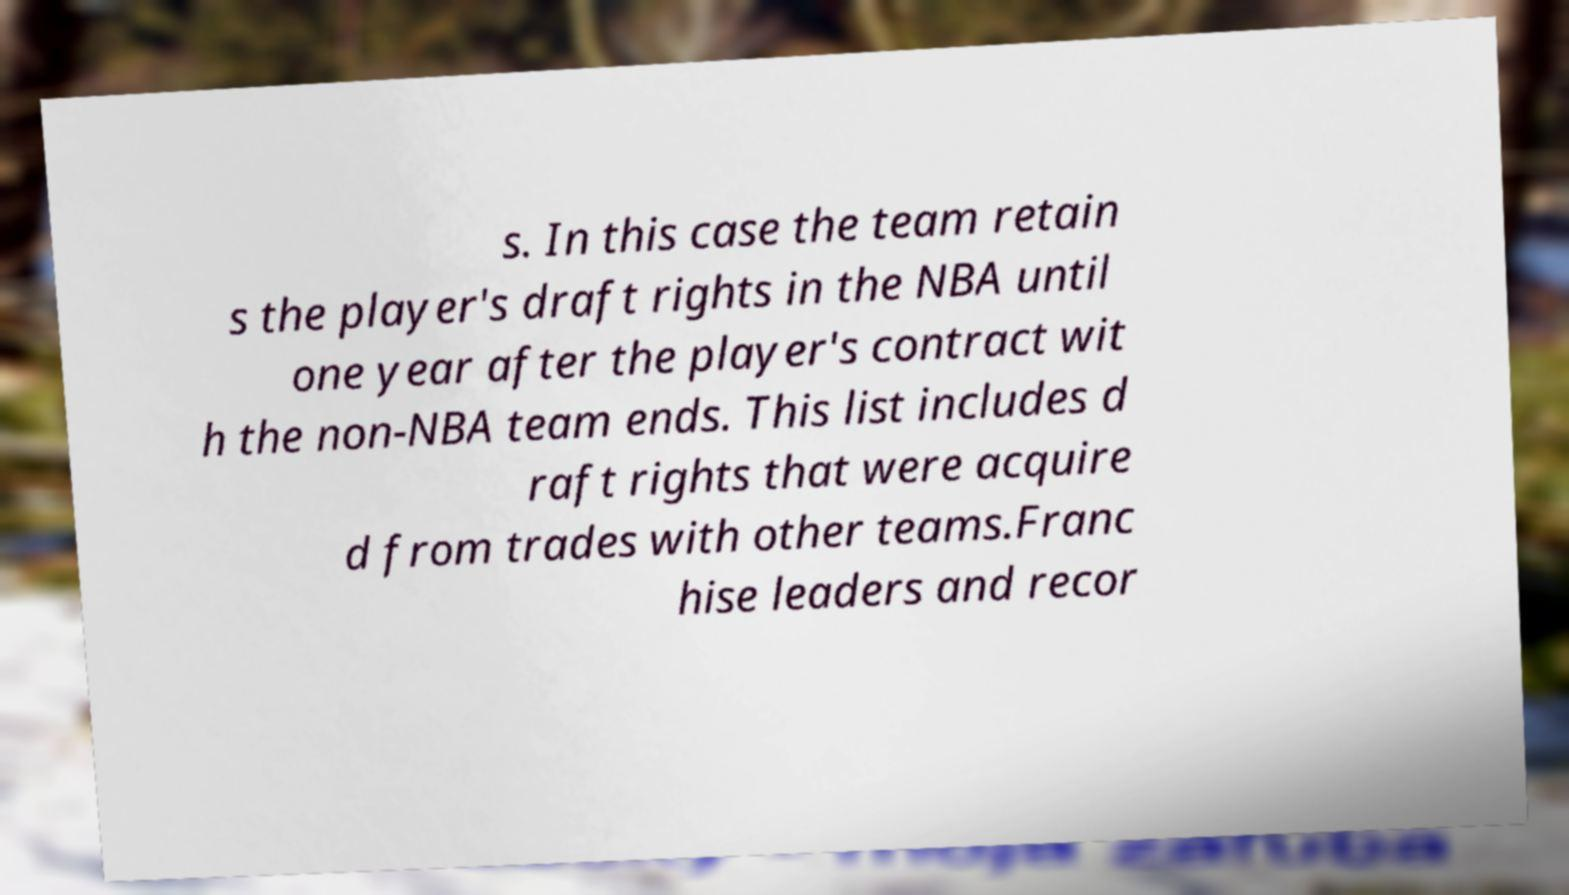Could you assist in decoding the text presented in this image and type it out clearly? s. In this case the team retain s the player's draft rights in the NBA until one year after the player's contract wit h the non-NBA team ends. This list includes d raft rights that were acquire d from trades with other teams.Franc hise leaders and recor 